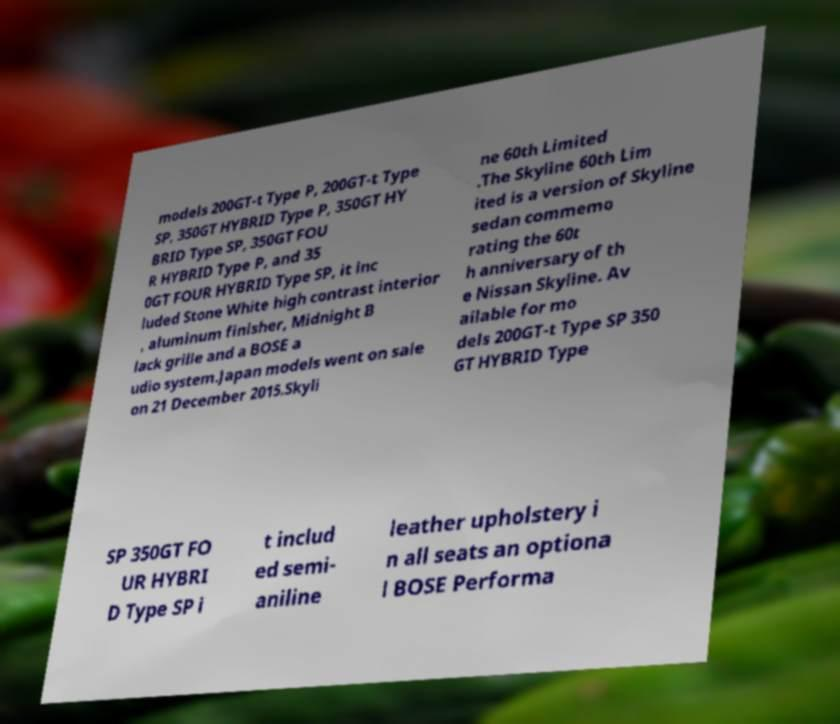What messages or text are displayed in this image? I need them in a readable, typed format. models 200GT-t Type P, 200GT-t Type SP, 350GT HYBRID Type P, 350GT HY BRID Type SP, 350GT FOU R HYBRID Type P, and 35 0GT FOUR HYBRID Type SP, it inc luded Stone White high contrast interior , aluminum finisher, Midnight B lack grille and a BOSE a udio system.Japan models went on sale on 21 December 2015.Skyli ne 60th Limited .The Skyline 60th Lim ited is a version of Skyline sedan commemo rating the 60t h anniversary of th e Nissan Skyline. Av ailable for mo dels 200GT-t Type SP 350 GT HYBRID Type SP 350GT FO UR HYBRI D Type SP i t includ ed semi- aniline leather upholstery i n all seats an optiona l BOSE Performa 